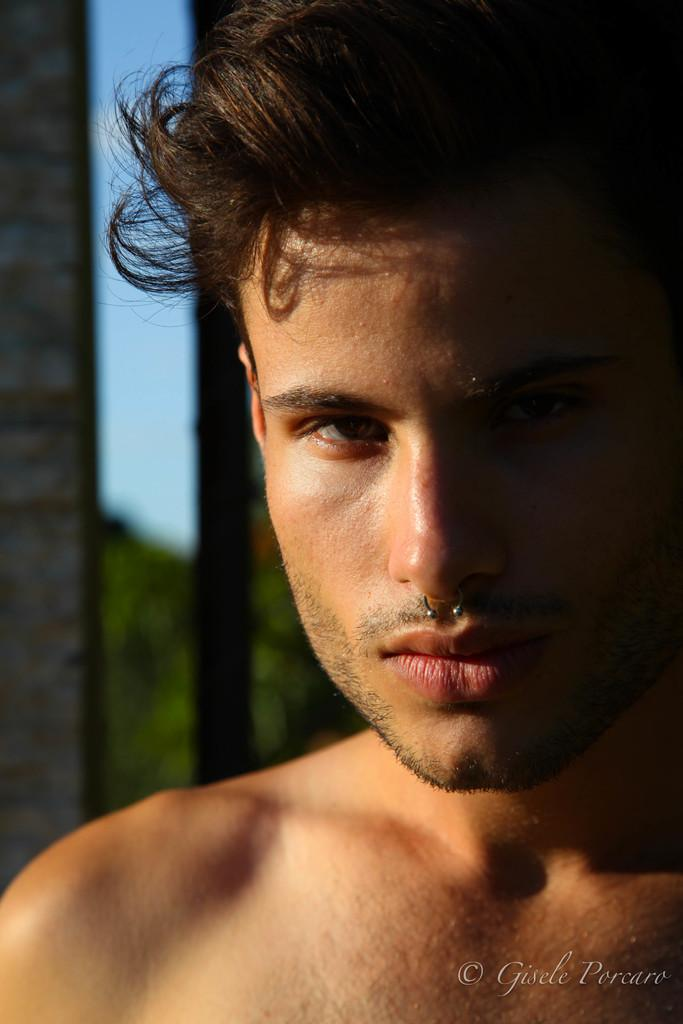What is the main subject of the image? There is a person in the image. Can you describe the background of the image? The background of the image is blurred. What else can be seen in the image besides the person? There is text visible on the image. How many cubs are playing with the person's tongue in the image? There are no cubs or tongues present in the image. What is the distribution of the text on the image? The distribution of the text cannot be determined from the image, as only its presence is mentioned. 